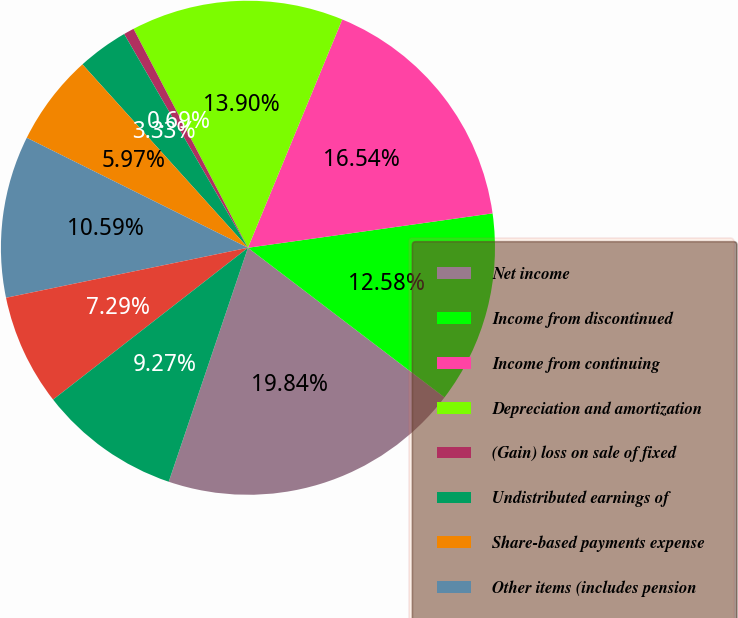Convert chart to OTSL. <chart><loc_0><loc_0><loc_500><loc_500><pie_chart><fcel>Net income<fcel>Income from discontinued<fcel>Income from continuing<fcel>Depreciation and amortization<fcel>(Gain) loss on sale of fixed<fcel>Undistributed earnings of<fcel>Share-based payments expense<fcel>Other items (includes pension<fcel>Accounts receivable<fcel>Inventories<nl><fcel>19.84%<fcel>12.58%<fcel>16.54%<fcel>13.9%<fcel>0.69%<fcel>3.33%<fcel>5.97%<fcel>10.59%<fcel>7.29%<fcel>9.27%<nl></chart> 